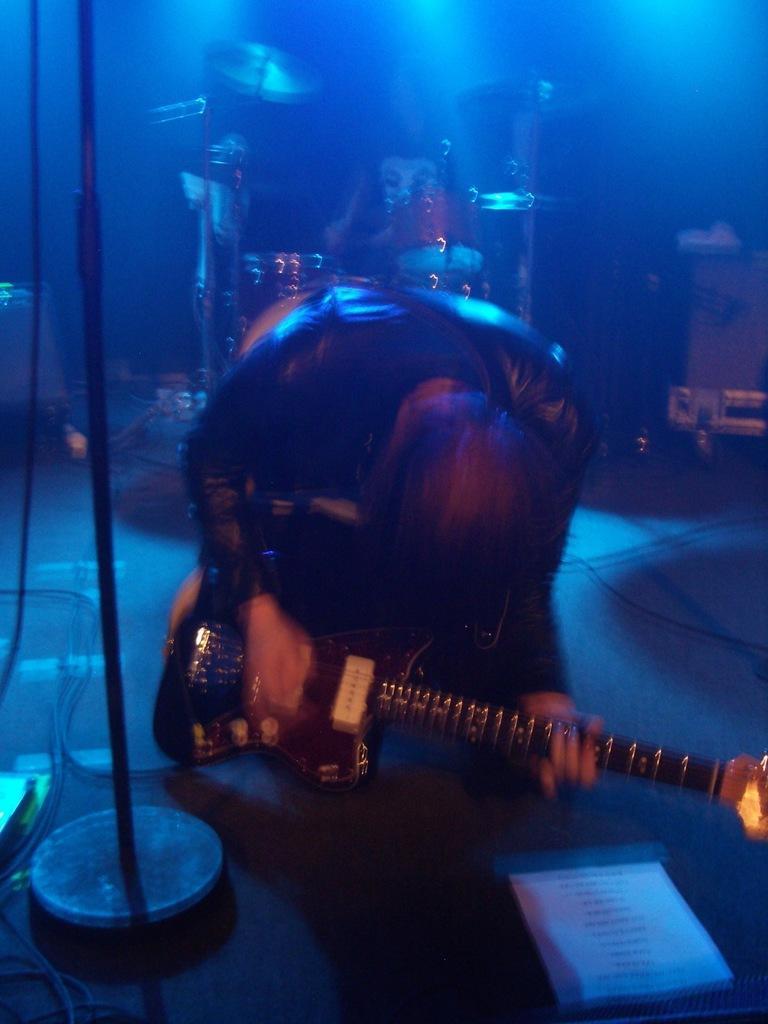Can you describe this image briefly? A person is playing a guitar. There is a stand. And in the background it is blue color and there is a drum in the background. 